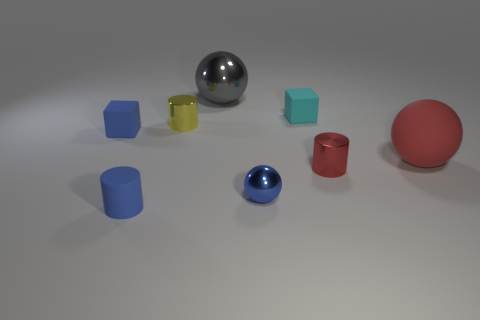Is the shape of the red rubber thing the same as the tiny red metallic thing?
Offer a very short reply. No. Are there any other things that are the same material as the big red sphere?
Make the answer very short. Yes. The gray metallic thing is what size?
Your answer should be very brief. Large. What color is the small metal thing that is to the left of the tiny red object and to the right of the yellow metal object?
Your answer should be very brief. Blue. Is the number of yellow metallic cylinders greater than the number of matte things?
Make the answer very short. No. How many objects are either gray balls or tiny cubes in front of the tiny yellow cylinder?
Make the answer very short. 2. Is the size of the yellow shiny object the same as the matte sphere?
Ensure brevity in your answer.  No. There is a tiny cyan cube; are there any blue things on the left side of it?
Provide a short and direct response. Yes. There is a rubber object that is both behind the tiny red metal thing and on the left side of the small blue metallic thing; what size is it?
Offer a terse response. Small. What number of objects are large green cubes or small rubber cubes?
Give a very brief answer. 2. 